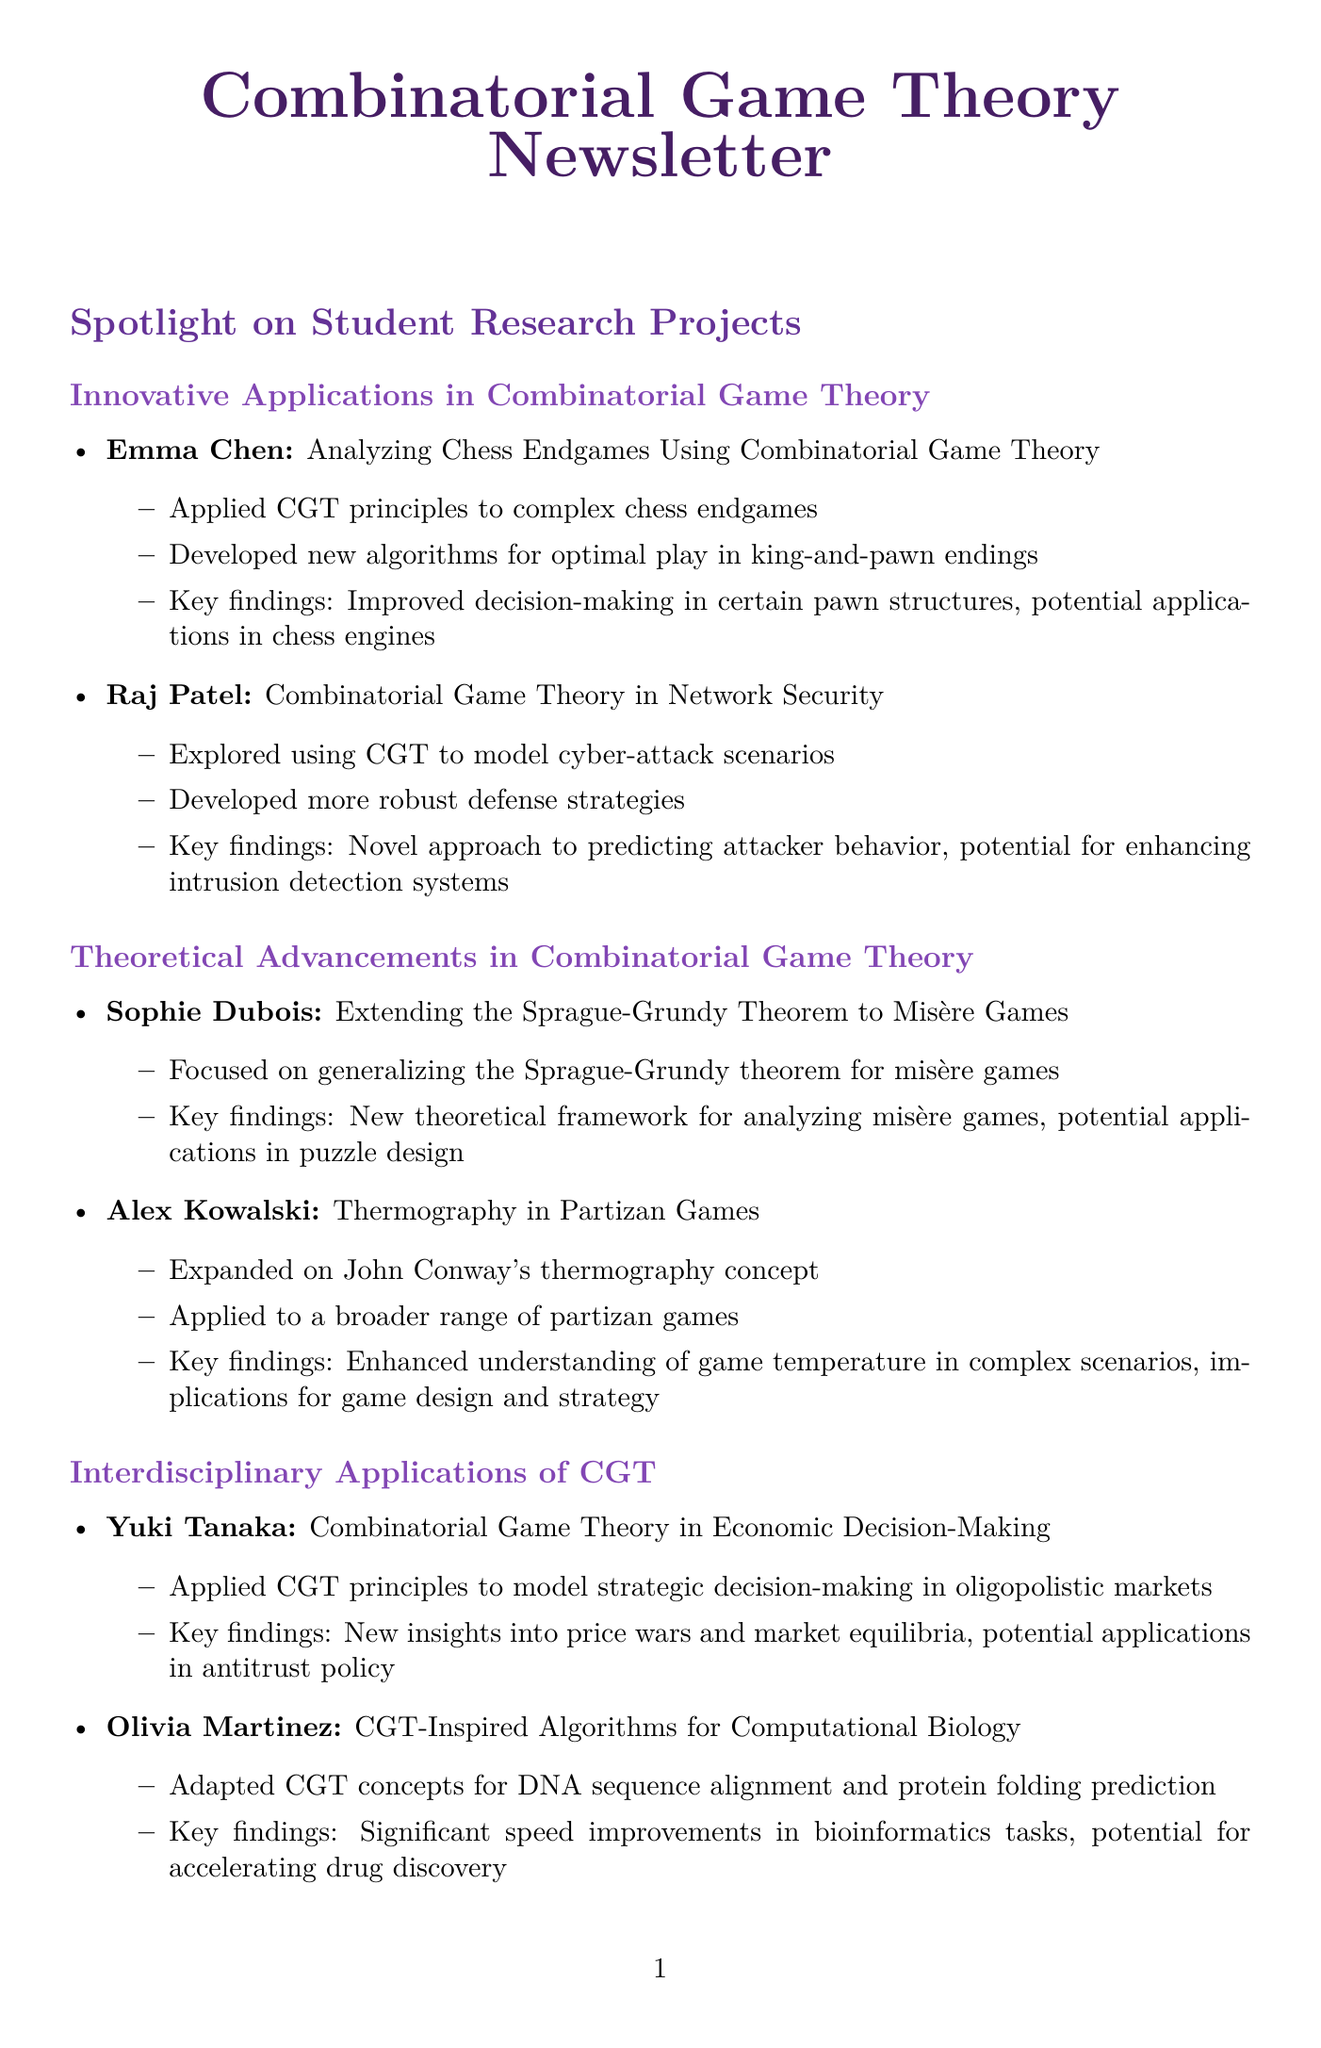What is the project title of Emma Chen? The project title is specified under her name in the document.
Answer: Analyzing Chess Endgames Using Combinatorial Game Theory Who is the featured professor in the Faculty Spotlight section? The document highlights a specific faculty member in this section.
Answer: Dr. Maria Hernandez What is the deadline for the CGT Research Grant? The deadline is mentioned clearly in the Upcoming Events and Opportunities section.
Answer: December 1, 2023 Which student project focuses on economic decision-making? This information can be found within the Interdisciplinary Applications of CGT section.
Answer: Combinatorial Game Theory in Economic Decision-Making What is the key finding of Raj Patel's project? Each student's key findings are detailed in their project descriptions.
Answer: Novel approach to predicting attacker behavior How many student projects are mentioned under Innovative Applications in Combinatorial Game Theory? The number of projects listed in that specific section directly answers this question.
Answer: Two What is the research focus of Dr. Maria Hernandez? The document specifies her area of research in the Faculty Spotlight section.
Answer: Combinatorial games on graphs What significant event is happening from October 15-17, 2023? This date outlines an event that is included in the Upcoming Events and Opportunities section.
Answer: Annual CGT Symposium 